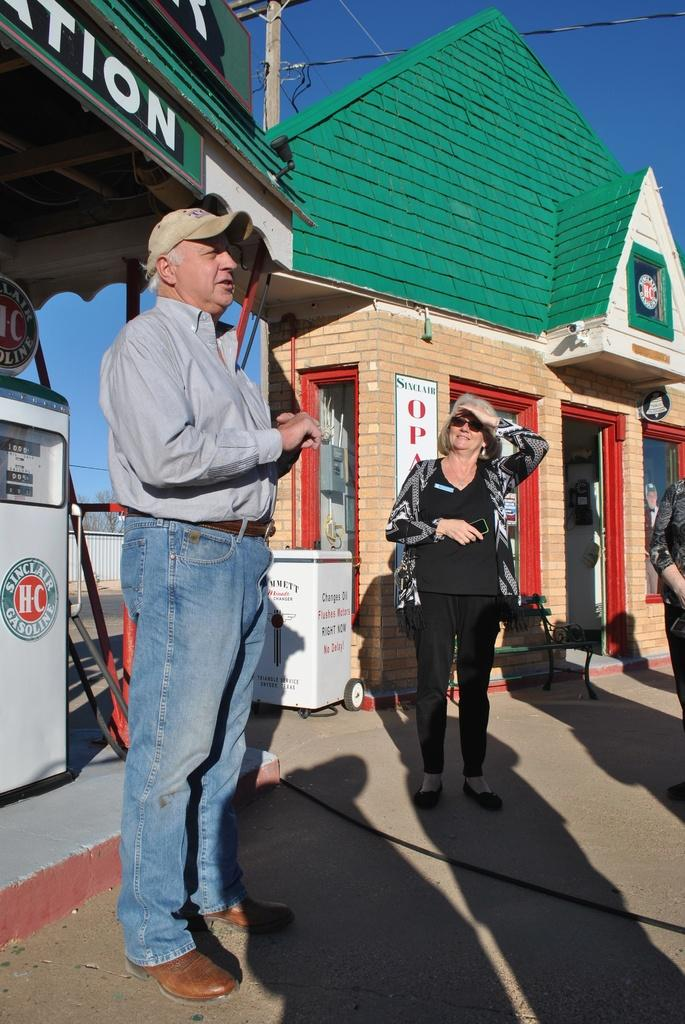What can be seen in the image in terms of people? There are people standing in the image. What type of structure is present in the image? There is a building in the image, which has glass windows. Can you describe any objects in the image? There is a white box and a green bench in the image. What architectural features can be observed in the image? There is fencing and a current pole in the image, along with wires. What natural elements are visible in the image? Trees are present in the image, and the sky is blue in color. Where is the basin located in the image? There is no basin present in the image. What type of hook can be seen attached to the current pole? There are no hooks visible on the current pole in the image. 